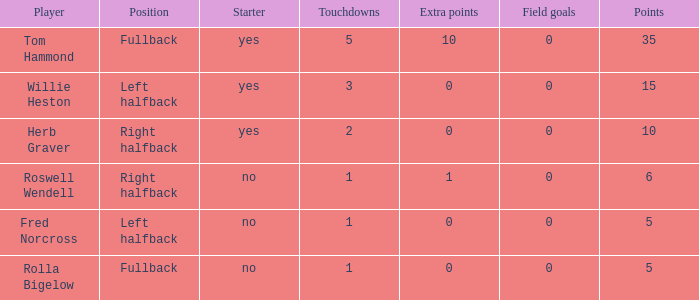What is the lowest number of touchdowns for left halfback WIllie Heston who has more than 15 points? None. Parse the table in full. {'header': ['Player', 'Position', 'Starter', 'Touchdowns', 'Extra points', 'Field goals', 'Points'], 'rows': [['Tom Hammond', 'Fullback', 'yes', '5', '10', '0', '35'], ['Willie Heston', 'Left halfback', 'yes', '3', '0', '0', '15'], ['Herb Graver', 'Right halfback', 'yes', '2', '0', '0', '10'], ['Roswell Wendell', 'Right halfback', 'no', '1', '1', '0', '6'], ['Fred Norcross', 'Left halfback', 'no', '1', '0', '0', '5'], ['Rolla Bigelow', 'Fullback', 'no', '1', '0', '0', '5']]} 